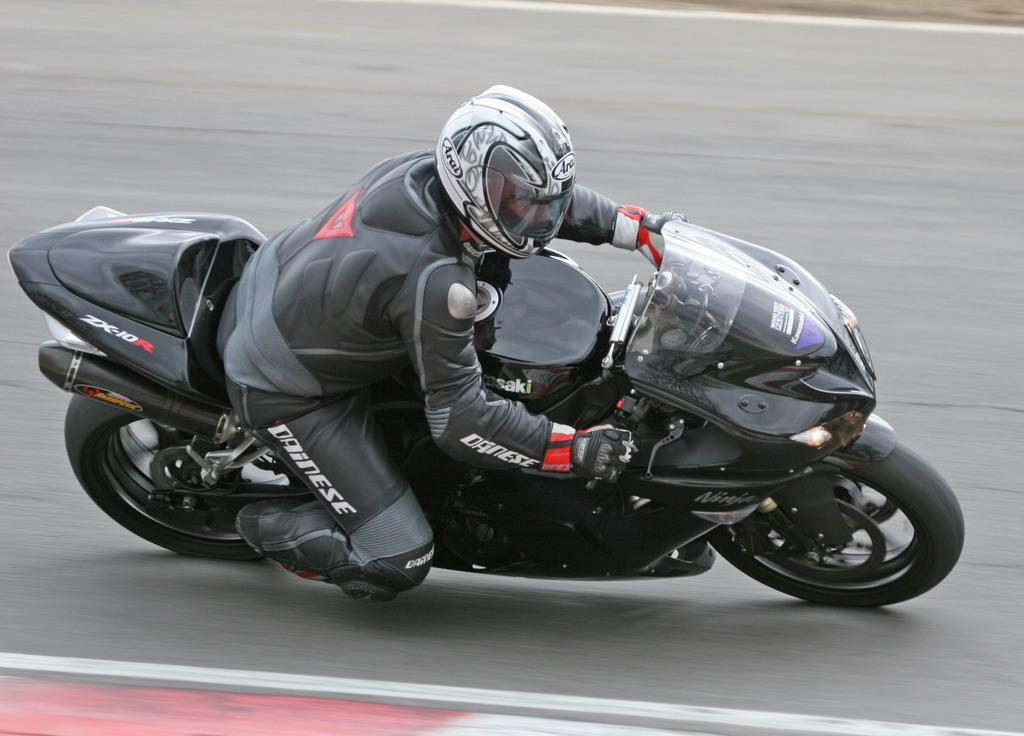What is the main subject of the picture? The main subject of the picture is a person. What is the person wearing? The person is wearing a black jacket and a helmet. What activity is the person engaged in? The person is riding a bike. What type of wind instrument can be seen on the table in the image? There is no wind instrument or table present in the image; it features a person riding a bike while wearing a black jacket and a helmet. 